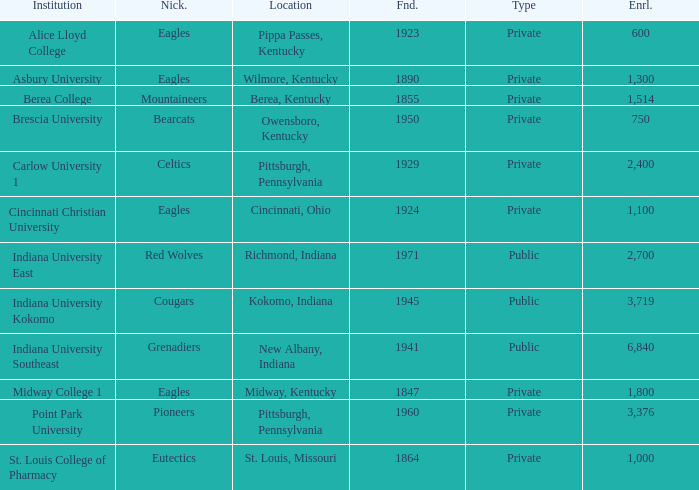Which college's enrollment is less than 1,000? Alice Lloyd College, Brescia University. 